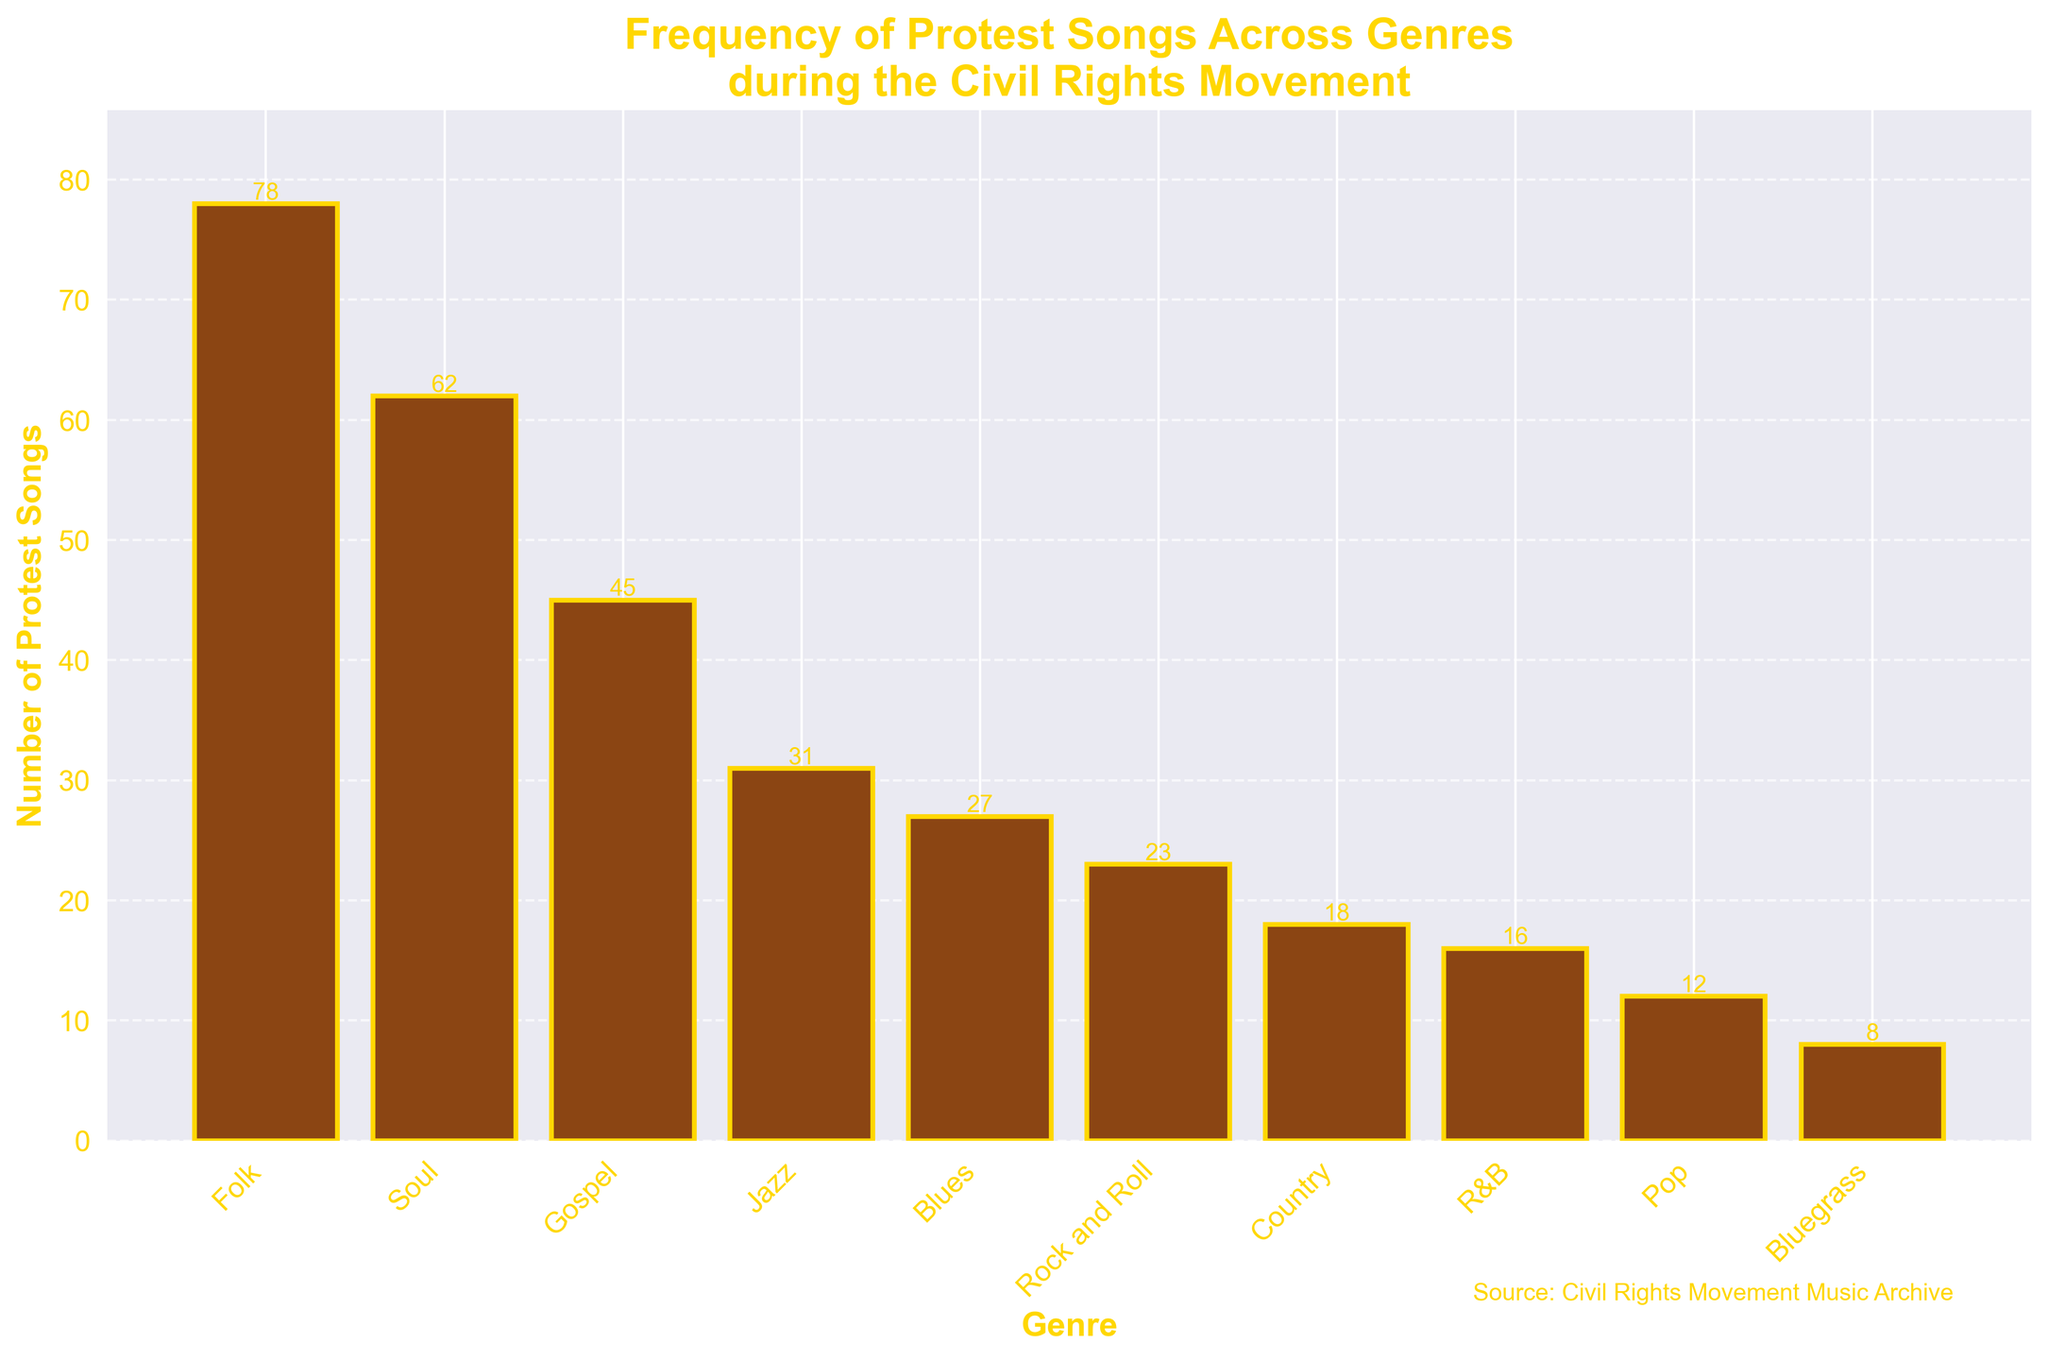what genre has the highest number of protest songs? Refer to the height of the bars in the chart. The bar representing "Folk" is the tallest.
Answer: Folk which genres have fewer than 20 protest songs? Identify the bars with heights corresponding to values less than 20. These genres are Country, R&B, Pop, and Bluegrass.
Answer: Country, R&B, Pop, Bluegrass how many more protest songs are there in Soul compared to Jazz? Refer to the values of Soul (62) and Jazz (31). Subtract the number for Jazz from Soul: 62 - 31 = 31 more protest songs.
Answer: 31 which genre has roughly half the number of protest songs as Gospel? Gospel has 45 protest songs. Half of 45 is 22.5. The bar closest to this value is Rock and Roll with 23.
Answer: Rock and Roll what is the combined total of protest songs in genres with more than 50 songs? Identify genres with more than 50 songs (Folk and Soul). Sum their values: 78 + 62 = 140.
Answer: 140 between Blues and Rock and Roll, which genre has fewer protest songs and by how much? Refer to the values: Blues (27) and Rock and Roll (23). Rock and Roll has fewer. Calculate the difference: 27 - 23 = 4.
Answer: Rock and Roll, 4 identify the color of the bars and the edge. Bars are colored brown and the bar edges are gold.
Answer: Brown and gold what is the average number of protest songs across all genres? Sum the values of all songs: 78 + 62 + 45 + 31 + 27 + 23 + 18 + 16 + 12 + 8 = 320. Divide by the number of genres: 320 / 10 = 32.
Answer: 32 